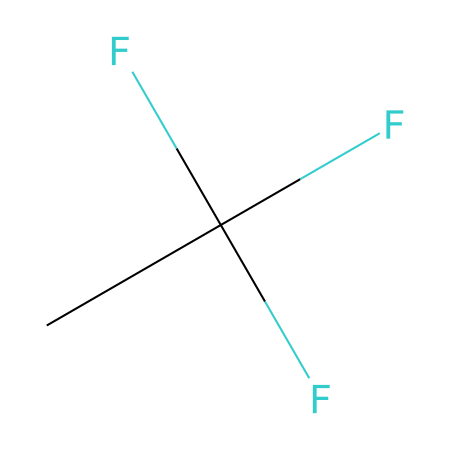What is the chemical name of the compound represented by this SMILES? The SMILES CC(F)(F)F indicates a molecule with one carbon (C) atom bonded to three fluorine (F) atoms, which is characteristic of trifluoromethane.
Answer: trifluoromethane How many carbon atoms are in the molecule? By analyzing the SMILES, there is one carbon atom (C) present at the start of the representation before the parentheses.
Answer: 1 How many fluorine atoms are attached to the carbon? The notation (F)(F)F shows three fluorine atoms bonded to the central carbon atom.
Answer: 3 What is the functional group present in this molecule? The presence of multiple fluorine atoms connected to a carbon indicates it contains a halogen functional group, specifically trifluoride.
Answer: trifluoride Is this compound a greenhouse gas? Many hydrofluorocarbons (HFCs), including trifluoromethane, are known to exhibit greenhouse gas properties due to their heat-trapping ability.
Answer: yes What type of compound is represented by this SMILES? The presence of carbon and halogens (fluorine) identifies this molecule as a hydrofluorocarbon (HFC), used as a refrigerant.
Answer: hydrofluorocarbon 